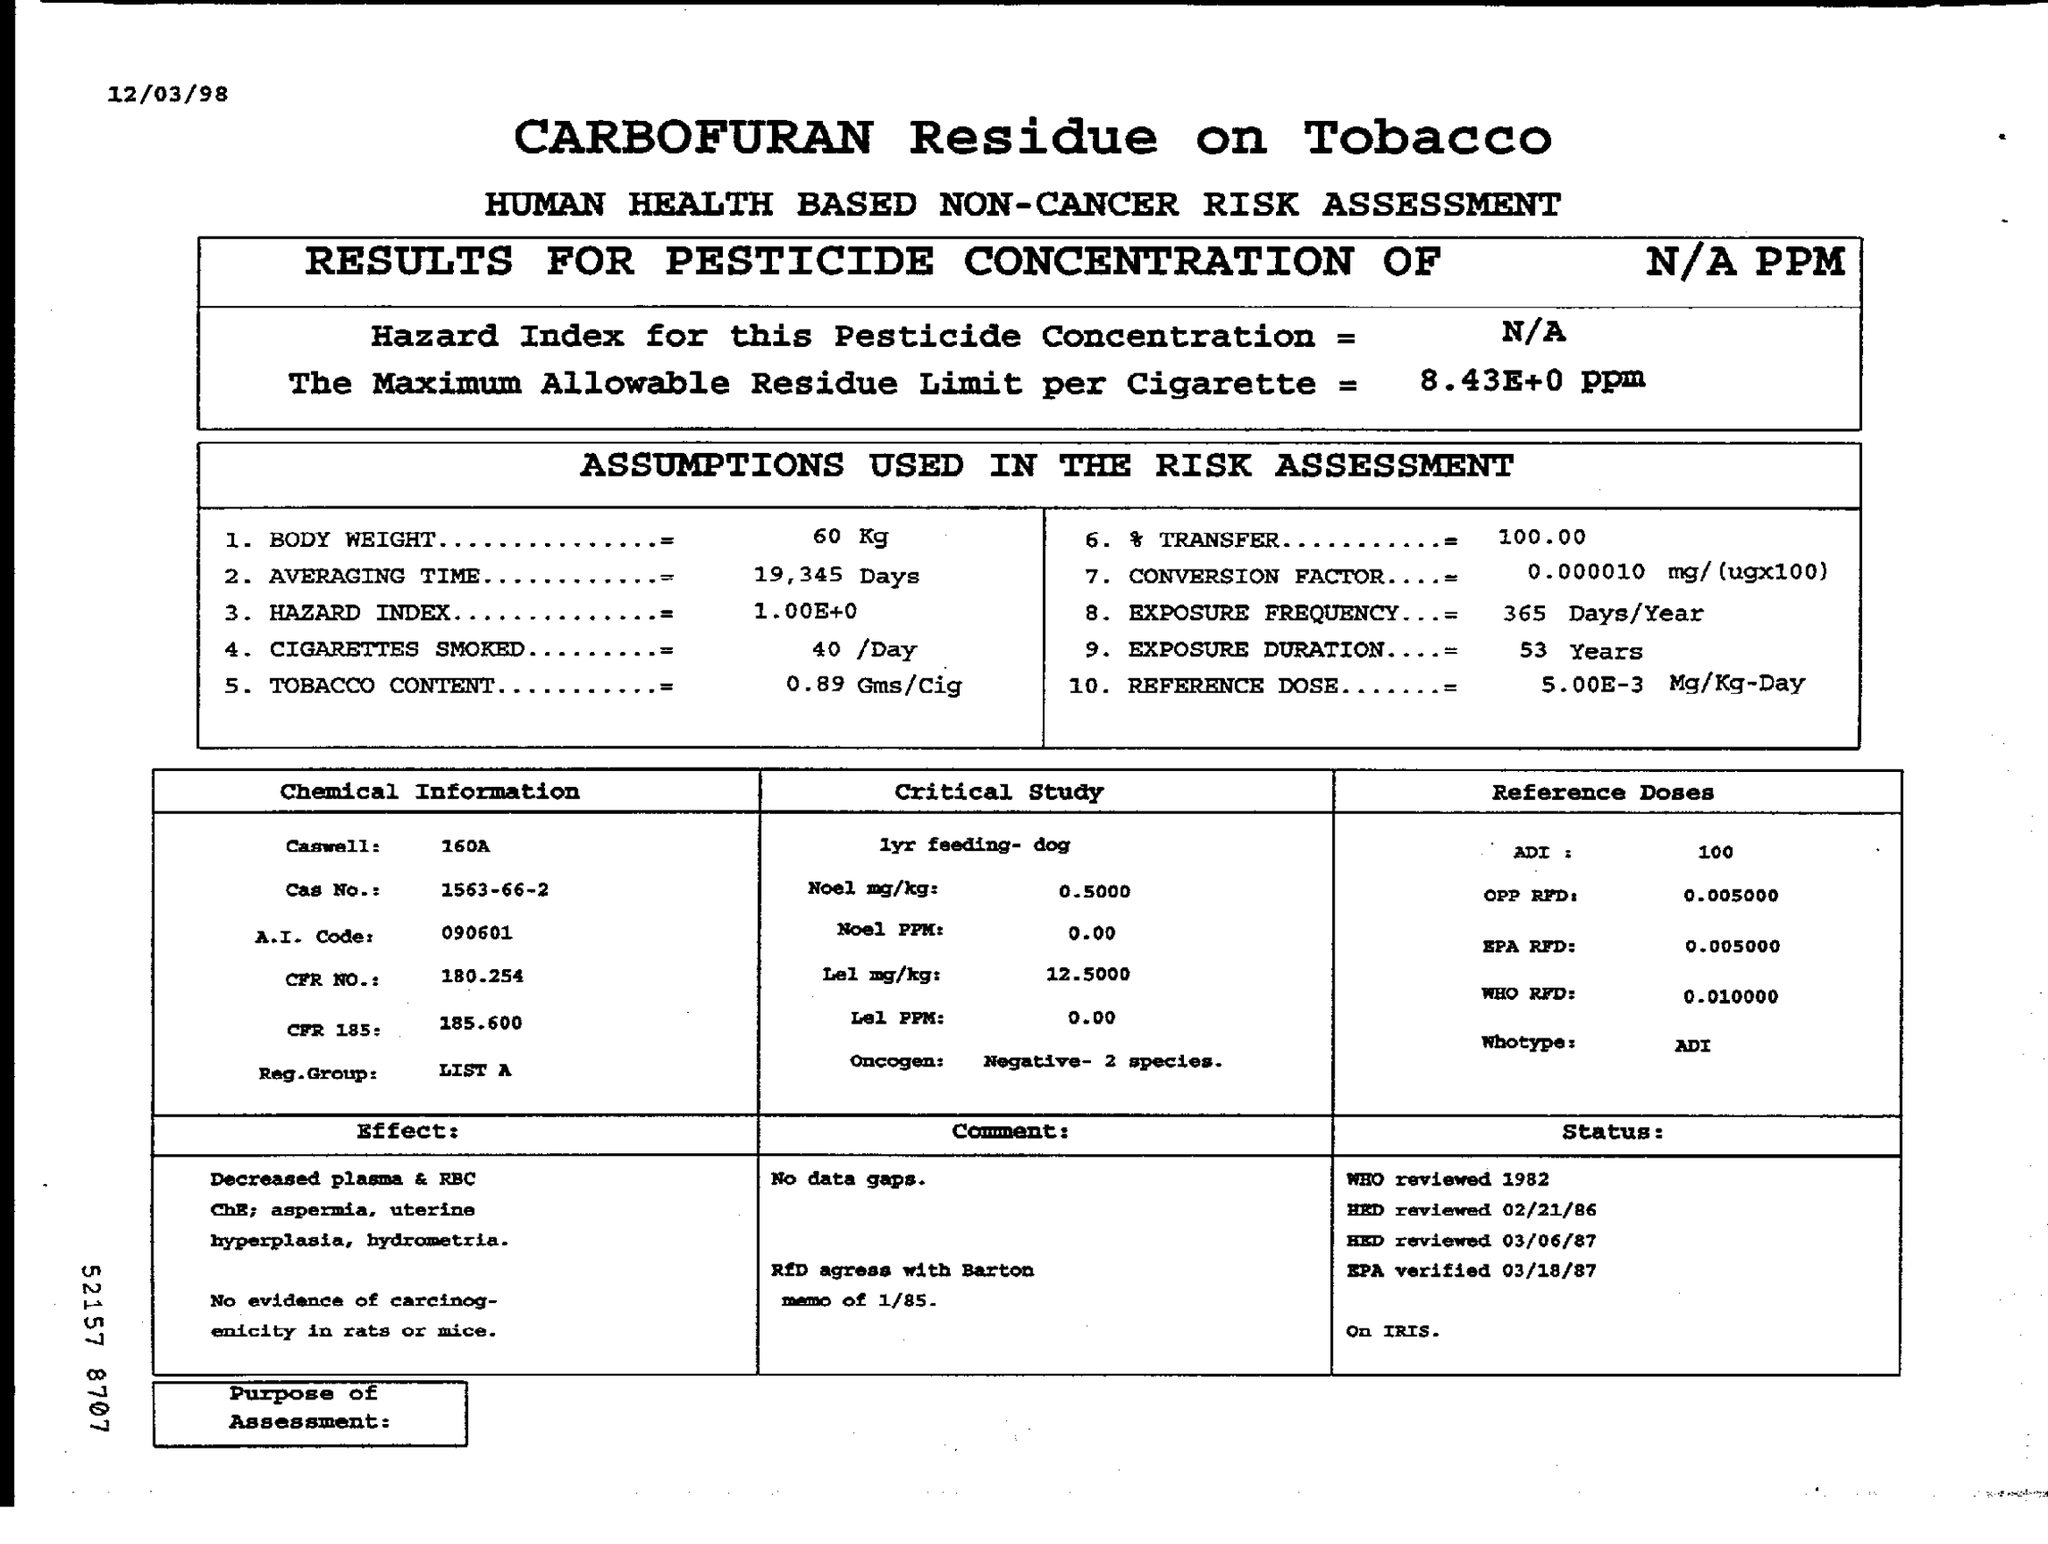What is Carbofuran, and why is it a concern for human health? Carbofuran is a systemic insecticide commonly used to control pests in a variety of crops. It can pose risks to human health if ingested, inhaled, or absorbed through the skin, as it is a potent neurotoxin that affects the central nervous system. 